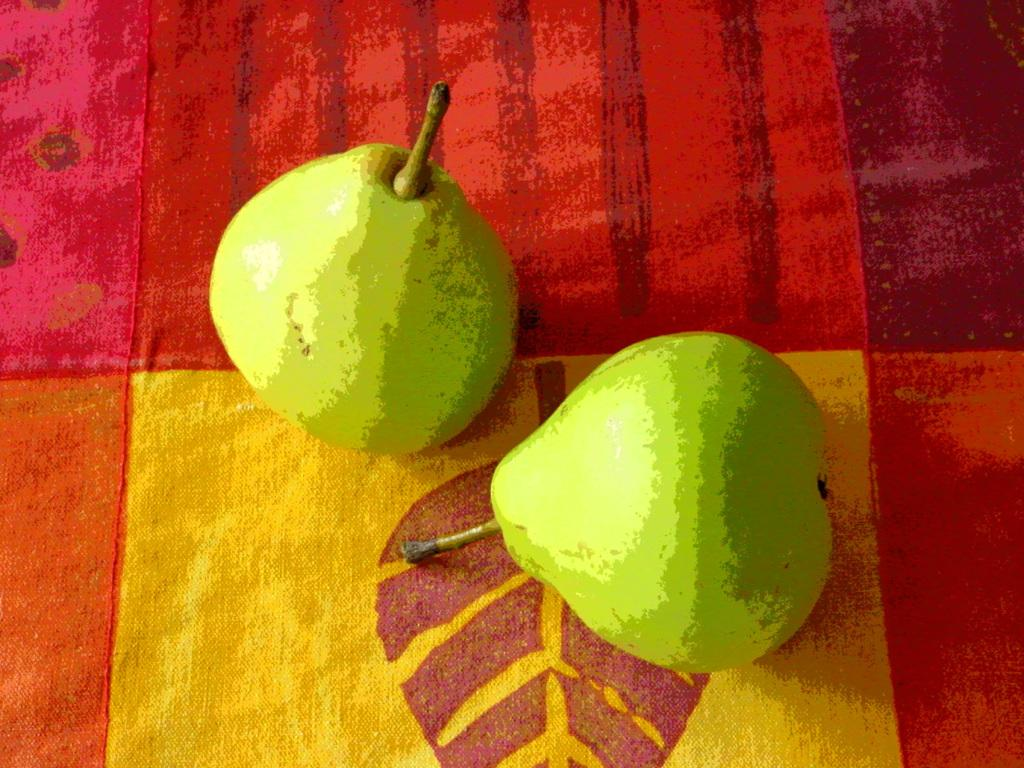What is the main object in the image? There is a cloth in the image. Can you describe the color pattern of the cloth? The cloth has a red and yellow color pattern. What else can be seen in the image besides the cloth? There are two green fruits in the image. What type of competition is taking place in the image? There is no competition present in the image; it features a cloth with a red and yellow color pattern and two green fruits. 